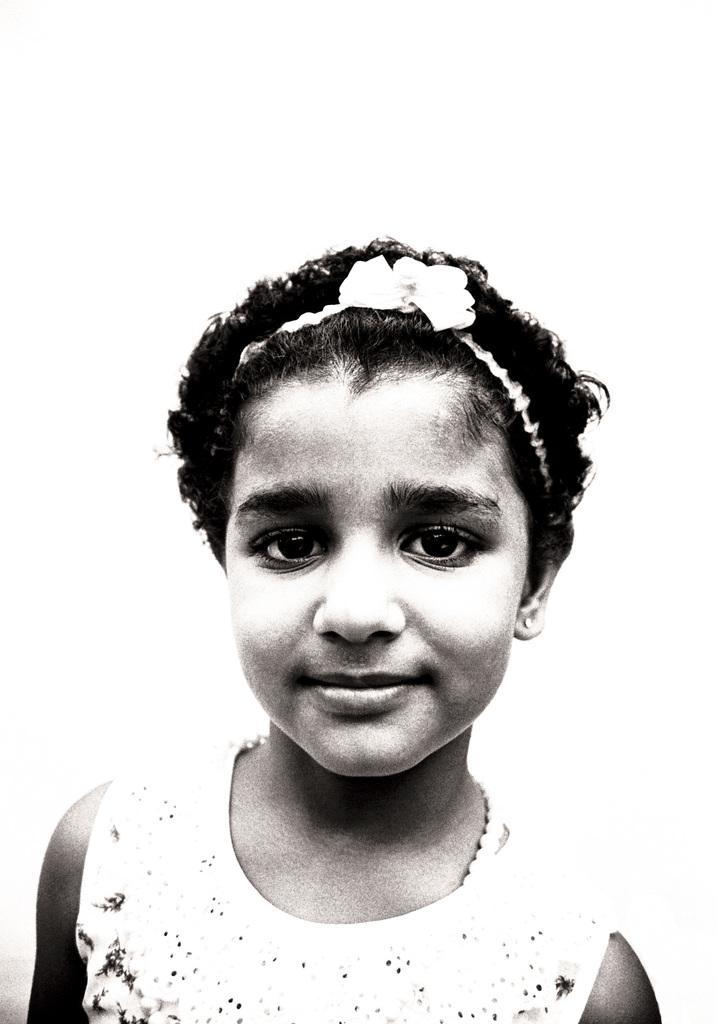Describe this image in one or two sentences. In this image we can see a person and the background is white. 